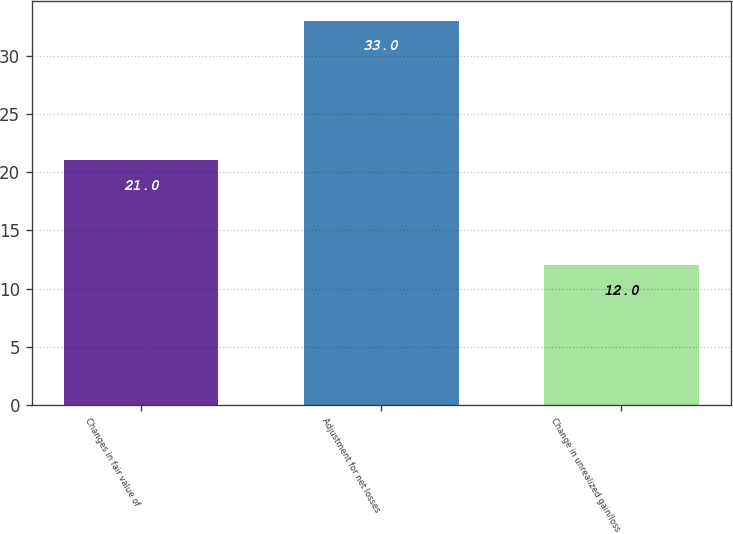Convert chart to OTSL. <chart><loc_0><loc_0><loc_500><loc_500><bar_chart><fcel>Changes in fair value of<fcel>Adjustment for net losses<fcel>Change in unrealized gain/loss<nl><fcel>21<fcel>33<fcel>12<nl></chart> 